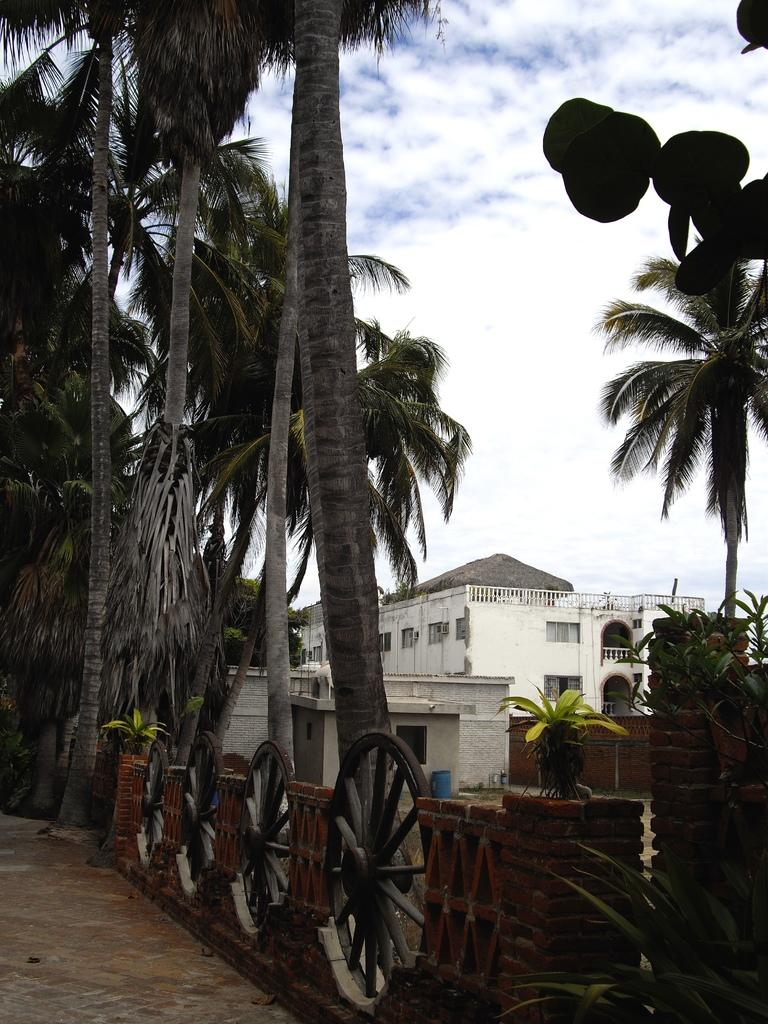What can be seen in the sky in the image? The sky is visible in the image. What type of structure is present in the image? There is a building in the image. Are there any residential structures in the image? Yes, there are houses in the image. What type of vegetation is present in the image? Trees and plants are visible in the image. What object with a cylindrical shape can be seen in the image? There is a barrel in the image. What type of transportation-related object is visible in the image? Wheels are observable in the image. How many balls are being juggled by the person in the image? There is no person present in the image, and therefore no one is juggling any balls. What type of crate is being used to store the surprise in the image? There is no crate or surprise present in the image. 